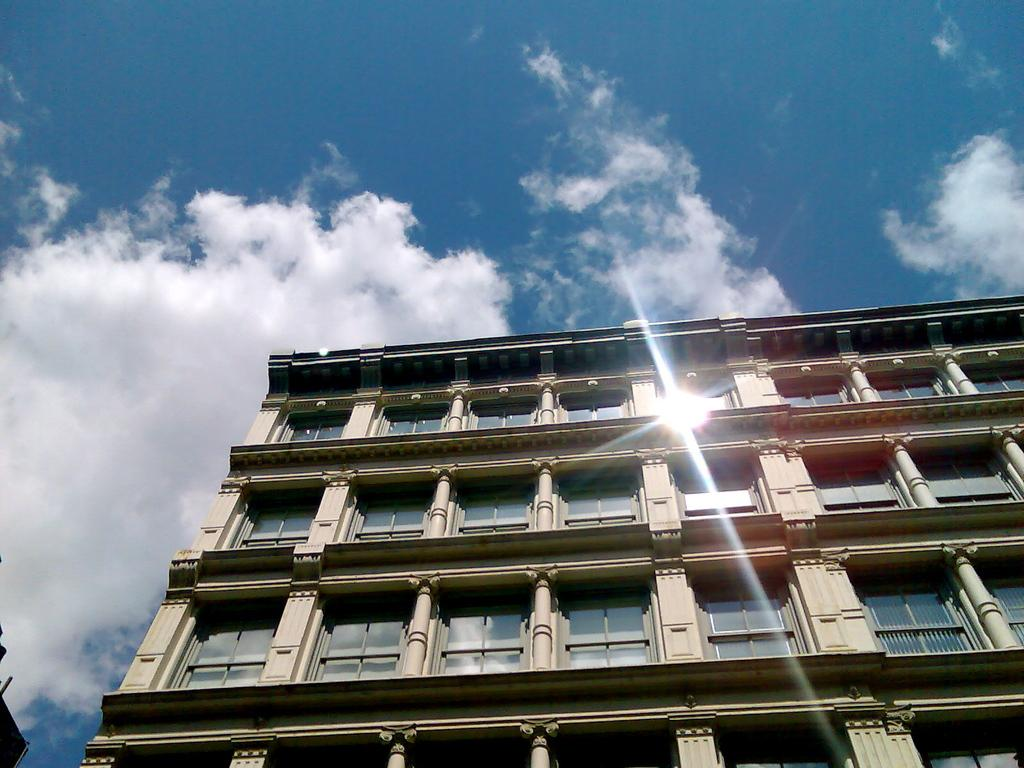What is the main structure in the image? There is a building in the image. What features can be observed on the building? The building has windows and railing. What can be seen in the background of the image? There are clouds and a blue sky in the background of the image. Can you tell me how many goats are standing on the railing of the building in the image? There are no goats present in the image; the building has railing, but no goats are visible. What type of beast is lurking in the shadows of the building in the image? There are no shadows or beasts present in the image; it features a building with windows and railing, along with clouds and a blue sky in the background. 